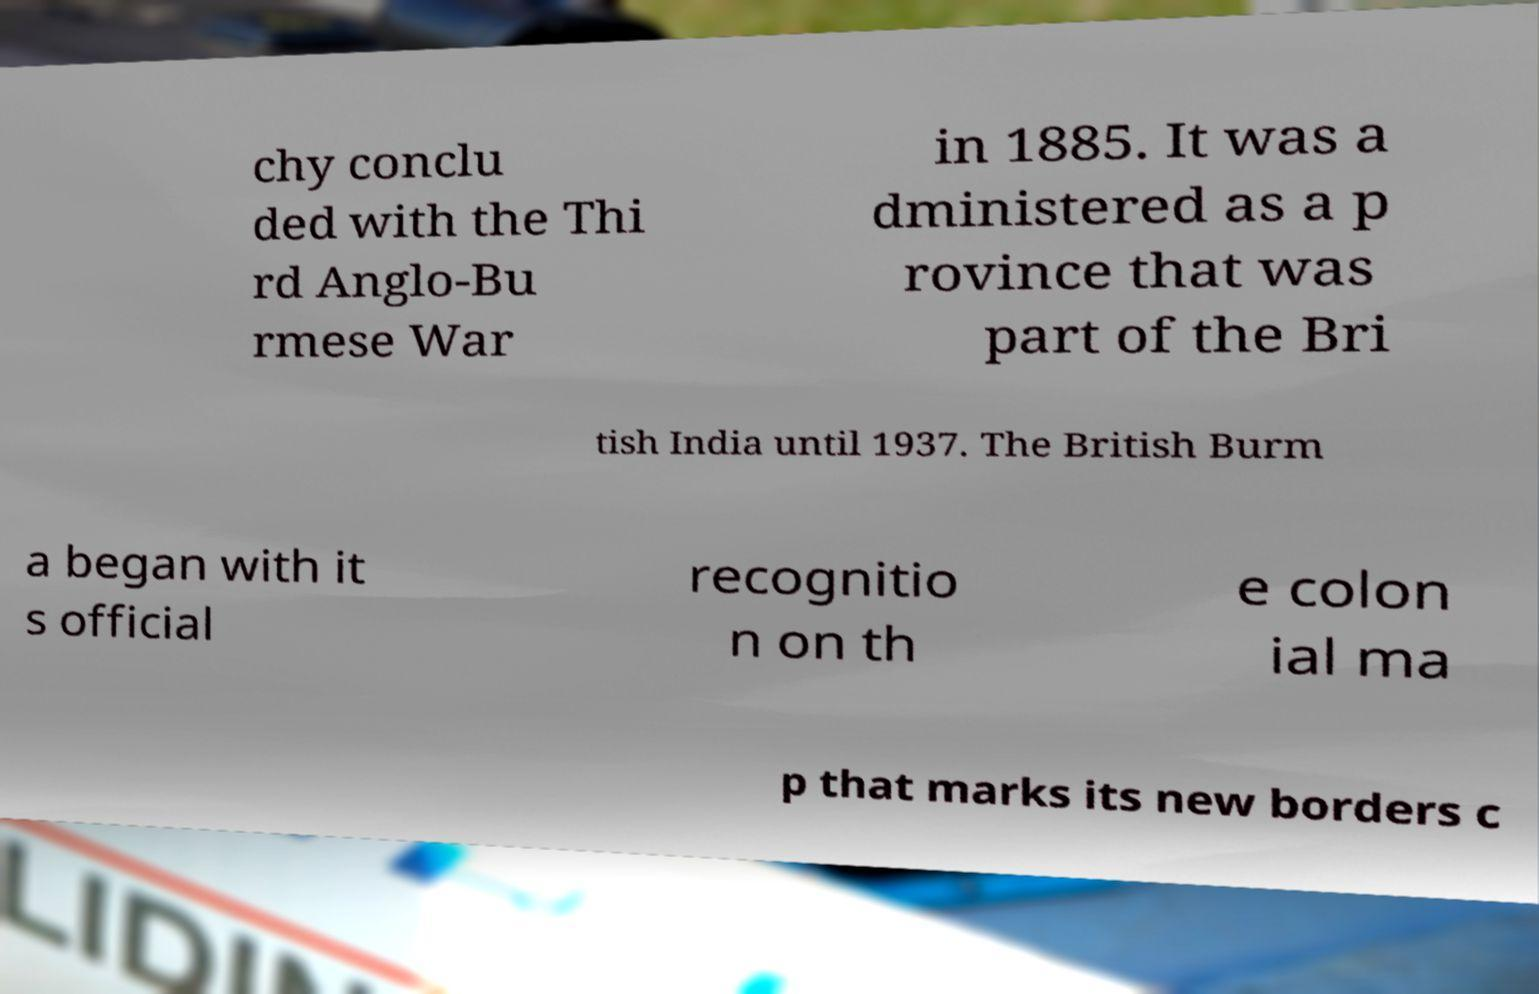Can you read and provide the text displayed in the image?This photo seems to have some interesting text. Can you extract and type it out for me? chy conclu ded with the Thi rd Anglo-Bu rmese War in 1885. It was a dministered as a p rovince that was part of the Bri tish India until 1937. The British Burm a began with it s official recognitio n on th e colon ial ma p that marks its new borders c 